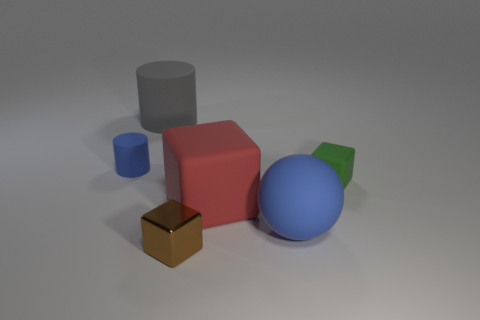Are there more big things that are on the left side of the big red thing than big gray cubes? After reviewing the image and considering the placement and size of the objects in relation to the large red cube, I can confirm that there are indeed more large objects to the left of the big red cube than there are big gray cubes in total. 